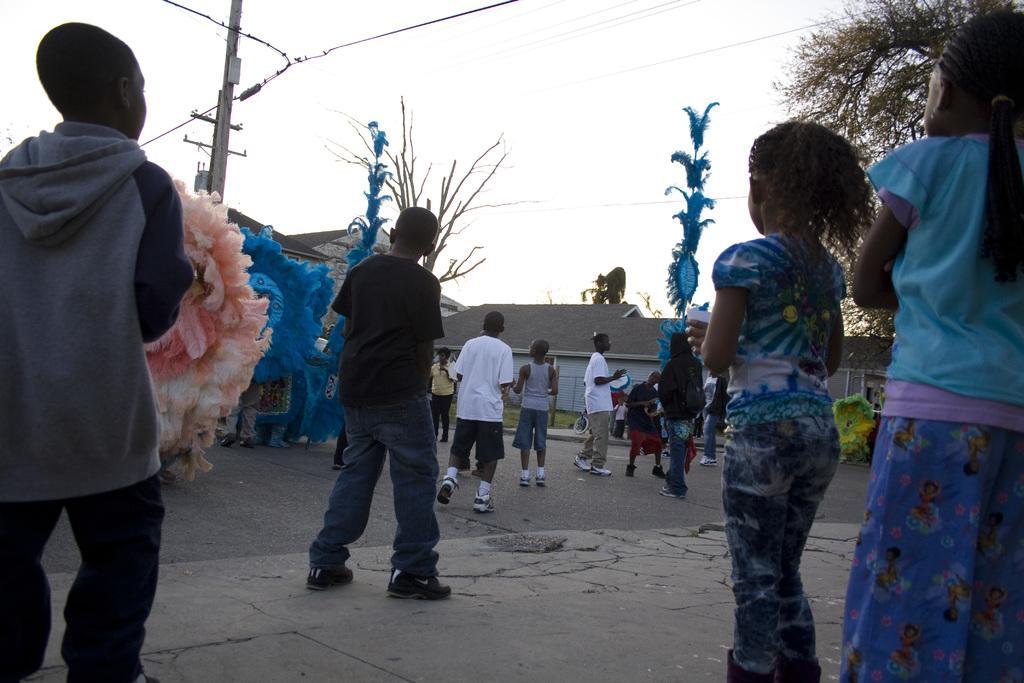How would you summarize this image in a sentence or two? In the image there are many people standing. There is a man holding a musical instrument in the hand. There is a person with blue color costume. There are two poles with blue color objects. In the background there are houses with walls and roofs. And also there is an electrical pole with wires. At the top of the image there is a sky. 